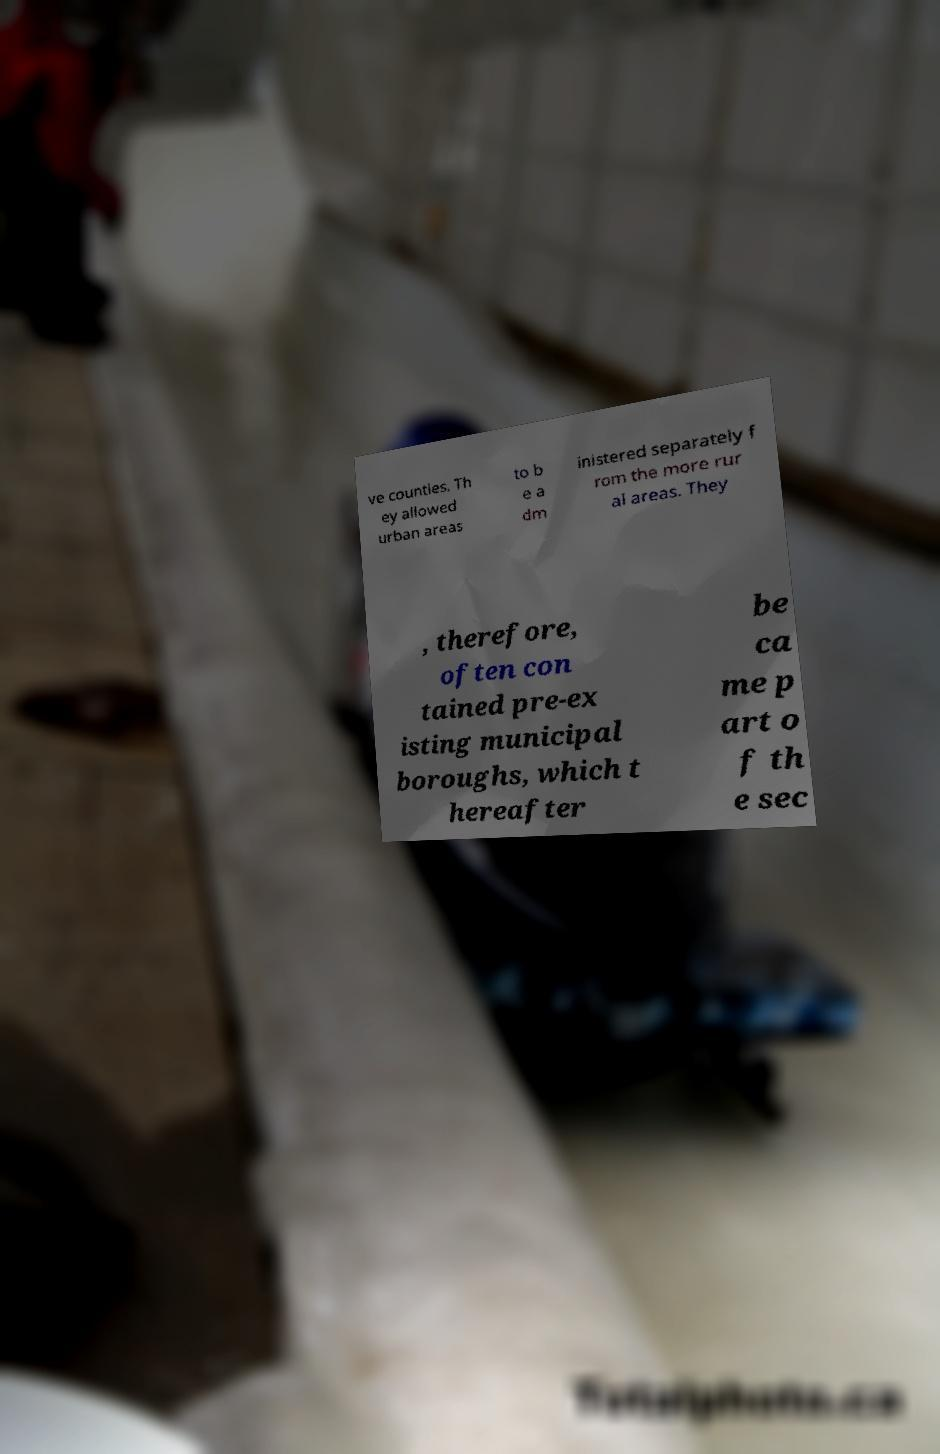There's text embedded in this image that I need extracted. Can you transcribe it verbatim? ve counties. Th ey allowed urban areas to b e a dm inistered separately f rom the more rur al areas. They , therefore, often con tained pre-ex isting municipal boroughs, which t hereafter be ca me p art o f th e sec 